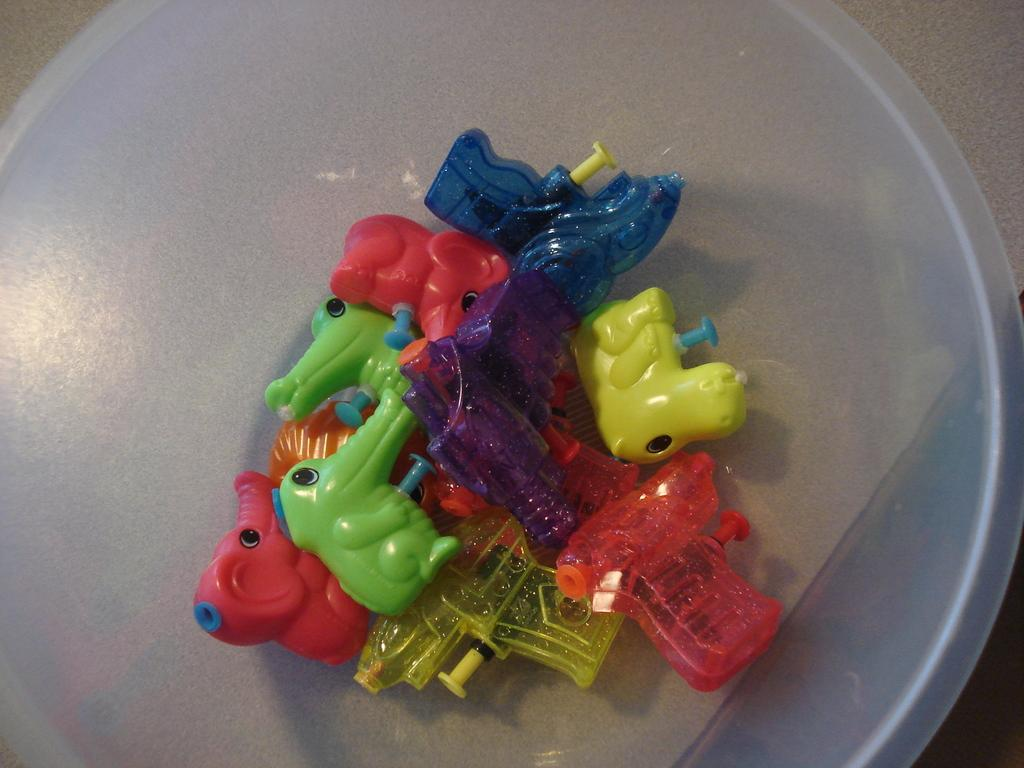What type of objects are in the image? There are tiny toys in the image. Where are the tiny toys located? The tiny toys are on a plastic transparent white lid. What time does the clock on the lid show in the image? There is no clock present in the image. How many legs can be seen on the earth in the image? There is no earth or legs visible in the image. 